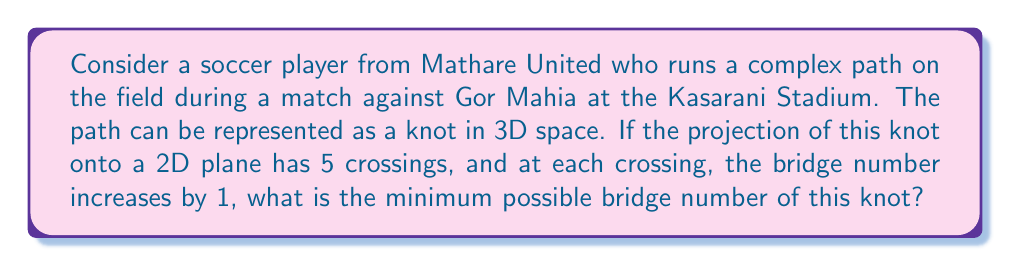Give your solution to this math problem. Let's approach this step-by-step:

1) The bridge number of a knot is defined as the minimum number of bridges needed in any bridge presentation of the knot.

2) In a 2D projection of a knot, each crossing can contribute to the bridge number. The minimum contribution is 0 (if it's an "under-crossing") and the maximum is 1 (if it's an "over-crossing").

3) Given that at each crossing, the bridge number increases by 1, we can assume that all crossings are "over-crossings" in the optimal bridge presentation.

4) The number of crossings in the 2D projection is 5.

5) However, the bridge number is not simply the number of crossings. We need to consider the minimum number of "maxima" in any presentation of the knot.

6) In the worst case scenario (which gives us the minimum bridge number), we can arrange the knot so that it goes up to a maximum, then down and up again for each crossing.

7) This arrangement would give us:
   - 1 initial maximum
   - 5 additional maxima (one for each crossing)

8) Therefore, the minimum possible bridge number is:

   $$ \text{Bridge Number} = 1 + 5 = 6 $$

This represents the most efficient way to arrange the knot while satisfying the given conditions.
Answer: 6 